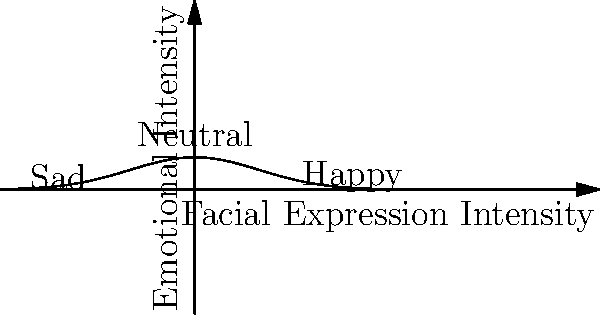In a counseling session, you notice a client's facial expression gradually changing. Using the graph, which represents emotional intensity based on facial expressions, how would you interpret a shift from point (0, 0.5) to (1.5, 0.2)? To interpret the shift in facial expression, let's follow these steps:

1. Identify the starting point:
   (0, 0.5) corresponds to the "Neutral" expression on the graph.

2. Identify the ending point:
   (1.5, 0.2) is located on the right side of the graph, near the "Happy" label.

3. Analyze the direction of movement:
   The shift is moving from left to right on the x-axis, indicating an increase in positive facial expression intensity.

4. Interpret the change in y-axis value:
   The y-value decreases from 0.5 to 0.2, suggesting a decrease in overall emotional intensity.

5. Combine the observations:
   The client's expression is changing from neutral to happy, but with less intensity than the peak of the curve.

6. Apply psychological interpretation:
   This shift likely indicates that the client is becoming more relaxed and positive as the session progresses, showing signs of improved mood or comfort level.
Answer: Shift from neutral to mildly happy expression 